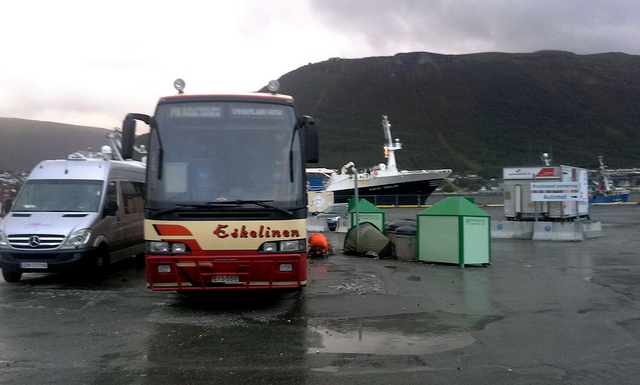Identify the text displayed in this image. Eskalinen 